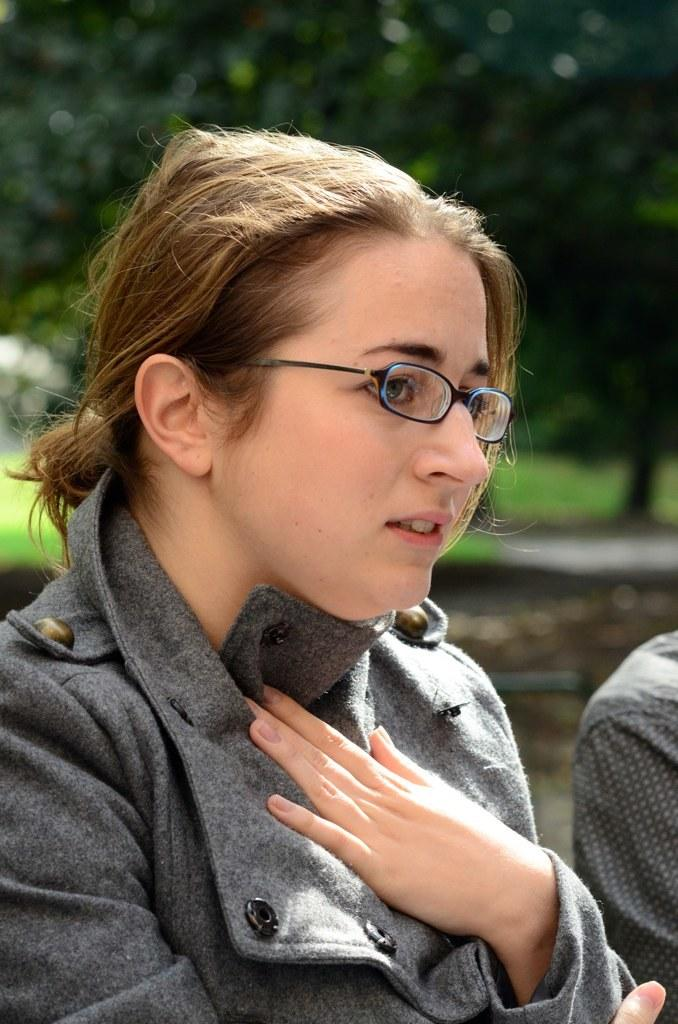Who is the main subject in the image? There is a woman in the image. What is the woman wearing? The woman is wearing a dress and spectacles. Can you describe the other person in the image? There is another person on the right side of the image. What can be seen in the background of the image? There are trees in the background of the image. What type of straw is being used by the woman in the image? There is no straw present in the image. Can you tell me how many wheels are visible in the image? There are no wheels visible in the image. 